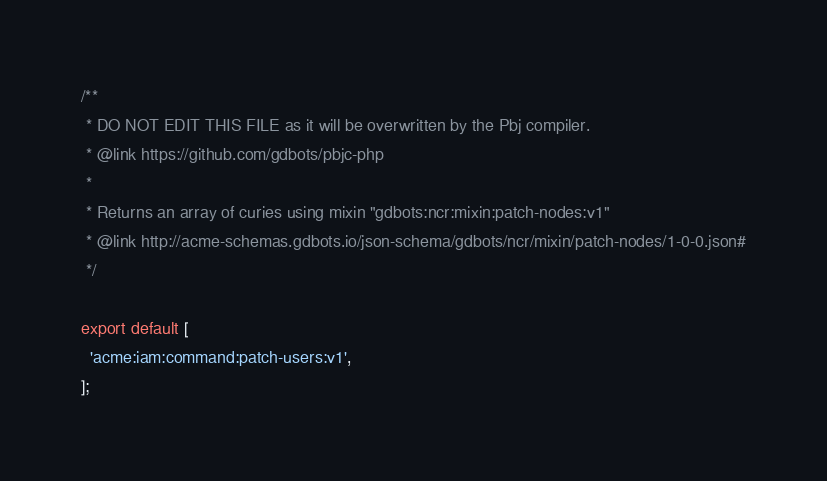Convert code to text. <code><loc_0><loc_0><loc_500><loc_500><_JavaScript_>/**
 * DO NOT EDIT THIS FILE as it will be overwritten by the Pbj compiler.
 * @link https://github.com/gdbots/pbjc-php
 *
 * Returns an array of curies using mixin "gdbots:ncr:mixin:patch-nodes:v1"
 * @link http://acme-schemas.gdbots.io/json-schema/gdbots/ncr/mixin/patch-nodes/1-0-0.json#
 */

export default [
  'acme:iam:command:patch-users:v1',
];
</code> 